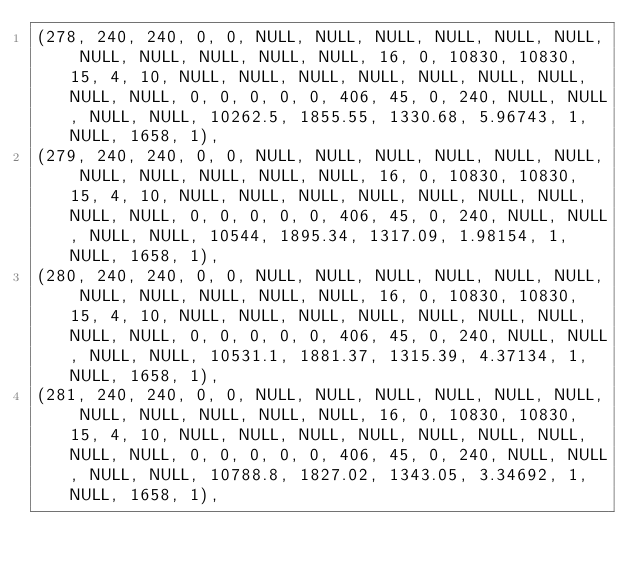Convert code to text. <code><loc_0><loc_0><loc_500><loc_500><_SQL_>(278, 240, 240, 0, 0, NULL, NULL, NULL, NULL, NULL, NULL, NULL, NULL, NULL, NULL, NULL, 16, 0, 10830, 10830, 15, 4, 10, NULL, NULL, NULL, NULL, NULL, NULL, NULL, NULL, NULL, 0, 0, 0, 0, 0, 406, 45, 0, 240, NULL, NULL, NULL, NULL, 10262.5, 1855.55, 1330.68, 5.96743, 1, NULL, 1658, 1),
(279, 240, 240, 0, 0, NULL, NULL, NULL, NULL, NULL, NULL, NULL, NULL, NULL, NULL, NULL, 16, 0, 10830, 10830, 15, 4, 10, NULL, NULL, NULL, NULL, NULL, NULL, NULL, NULL, NULL, 0, 0, 0, 0, 0, 406, 45, 0, 240, NULL, NULL, NULL, NULL, 10544, 1895.34, 1317.09, 1.98154, 1, NULL, 1658, 1),
(280, 240, 240, 0, 0, NULL, NULL, NULL, NULL, NULL, NULL, NULL, NULL, NULL, NULL, NULL, 16, 0, 10830, 10830, 15, 4, 10, NULL, NULL, NULL, NULL, NULL, NULL, NULL, NULL, NULL, 0, 0, 0, 0, 0, 406, 45, 0, 240, NULL, NULL, NULL, NULL, 10531.1, 1881.37, 1315.39, 4.37134, 1, NULL, 1658, 1),
(281, 240, 240, 0, 0, NULL, NULL, NULL, NULL, NULL, NULL, NULL, NULL, NULL, NULL, NULL, 16, 0, 10830, 10830, 15, 4, 10, NULL, NULL, NULL, NULL, NULL, NULL, NULL, NULL, NULL, 0, 0, 0, 0, 0, 406, 45, 0, 240, NULL, NULL, NULL, NULL, 10788.8, 1827.02, 1343.05, 3.34692, 1, NULL, 1658, 1),</code> 